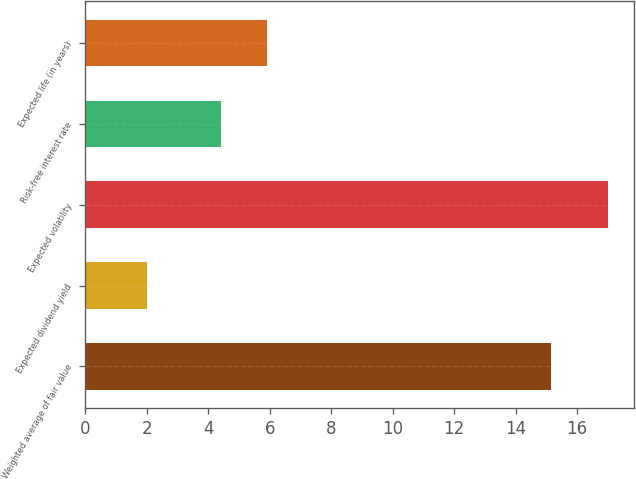<chart> <loc_0><loc_0><loc_500><loc_500><bar_chart><fcel>Weighted average of fair value<fcel>Expected dividend yield<fcel>Expected volatility<fcel>Risk-free interest rate<fcel>Expected life (in years)<nl><fcel>15.15<fcel>2<fcel>17<fcel>4.42<fcel>5.92<nl></chart> 